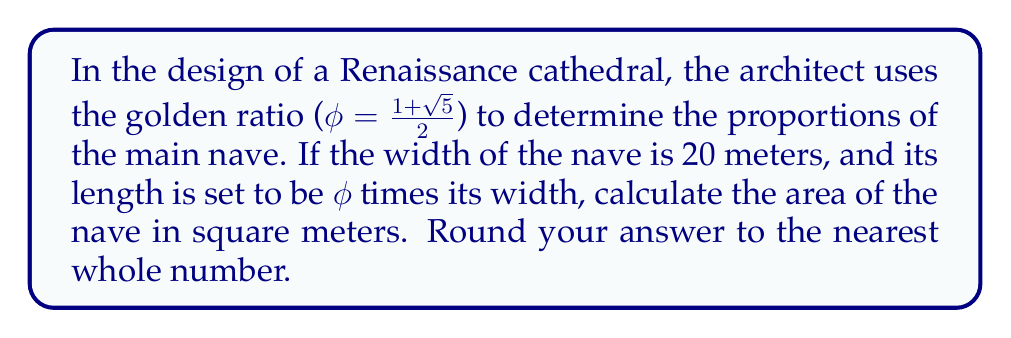Give your solution to this math problem. Let's approach this step-by-step:

1) We're given that the width of the nave is 20 meters.

2) The length is set to be $\phi$ times the width. We can express this as:
   $$ \text{Length} = \phi \times \text{Width} $$

3) We know that $\phi = \frac{1+\sqrt{5}}{2}$. Let's calculate this value:
   $$ \phi = \frac{1+\sqrt{5}}{2} \approx 1.61803398875 $$

4) Now we can calculate the length:
   $$ \text{Length} = 1.61803398875 \times 20 = 32.3606797750 \text{ meters} $$

5) The area of a rectangle is given by length times width. So:
   $$ \text{Area} = \text{Length} \times \text{Width} $$
   $$ \text{Area} = 32.3606797750 \times 20 = 647.2135955 \text{ square meters} $$

6) Rounding to the nearest whole number:
   $$ \text{Area} \approx 647 \text{ square meters} $$

This use of the golden ratio in architectural design creates a visually pleasing proportion that was highly valued during the Renaissance period, reflecting the harmonious blend of art and mathematics in classical architecture.
Answer: 647 square meters 